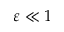Convert formula to latex. <formula><loc_0><loc_0><loc_500><loc_500>\varepsilon \ll 1</formula> 